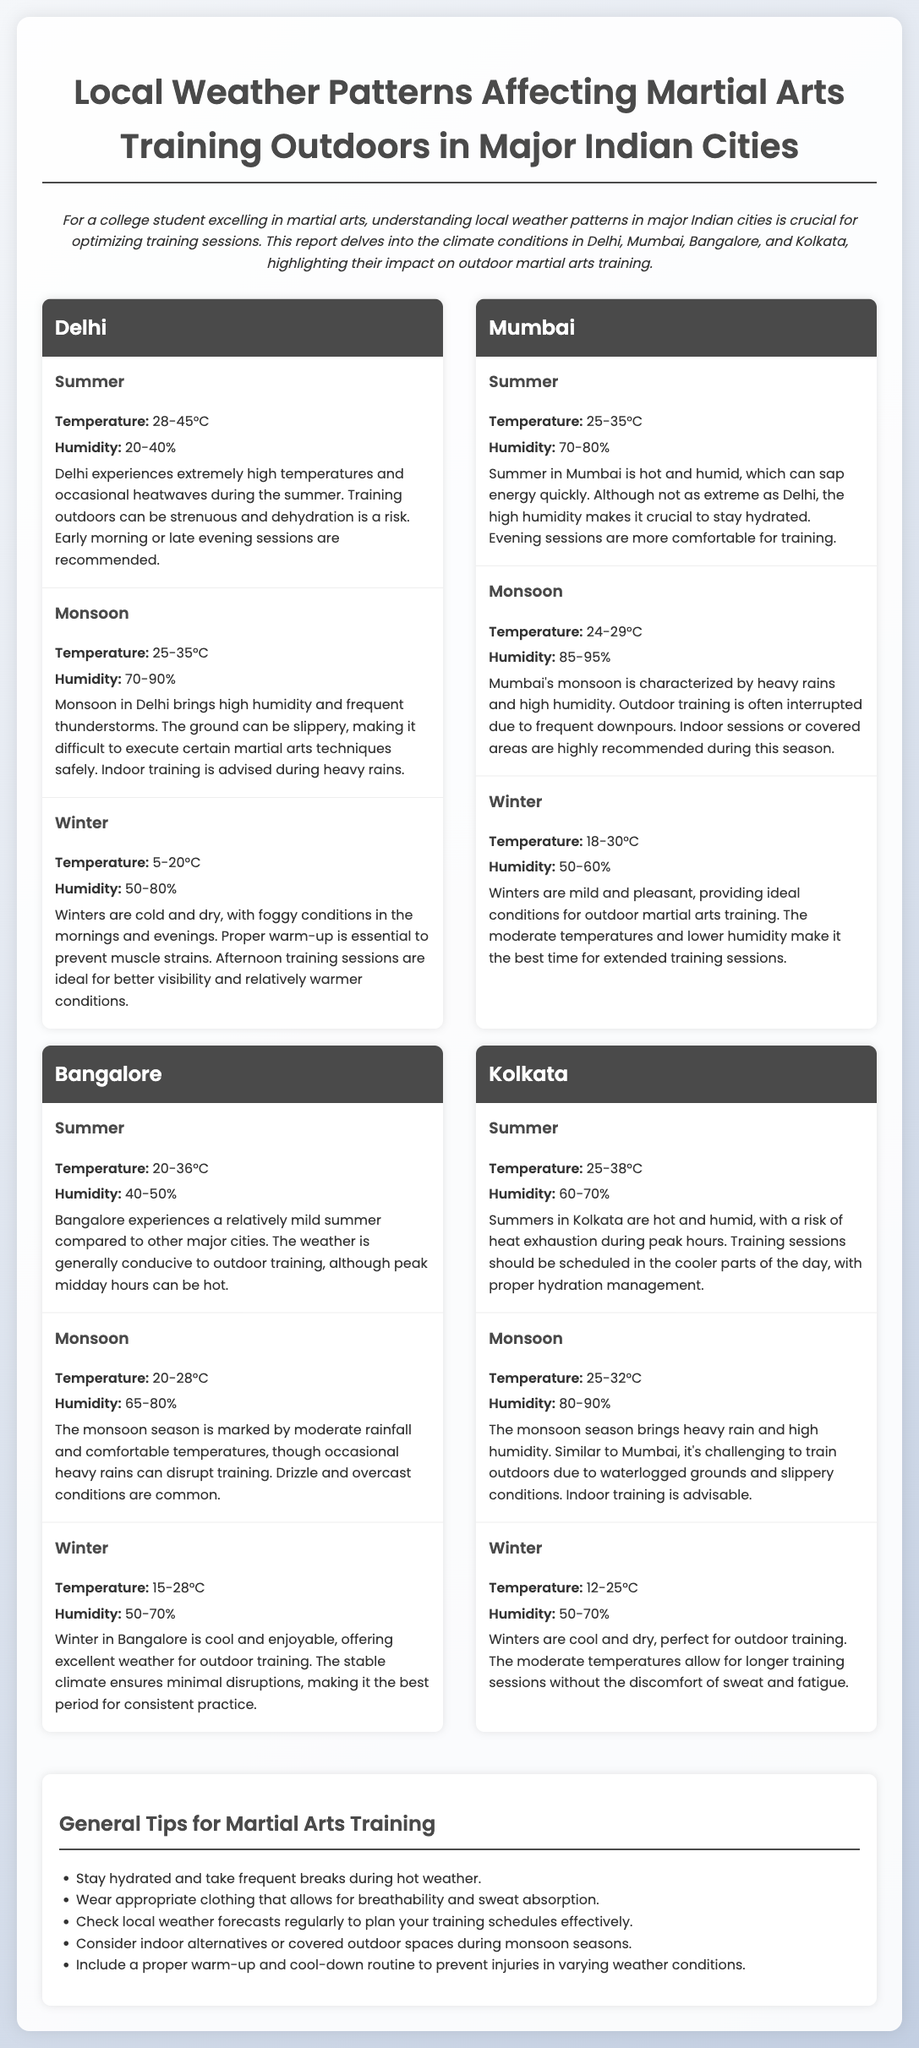What is the recommended training time during Delhi's summer? Delhi's summer experiences extremely high temperatures, and early morning or late evening sessions are recommended to avoid heat.
Answer: Early morning or late evening sessions What is the humidity range during Mumbai's winter? Mumbai's winter has a humidity range of 50-60%, as indicated for the winter season in the document.
Answer: 50-60% What is the temperature range in Bangalore during monsoon? The temperature range during the monsoon season in Bangalore is between 20-28 degrees Celsius, as mentioned in the document.
Answer: 20-28°C What training method is advised during heavy rains in Delhi? Indoor training is advised during heavy rains in Delhi due to high humidity and frequently slippery grounds.
Answer: Indoor training Which city has the highest summer temperature range? Delhi has the highest summer temperature range of 28-45 degrees Celsius among the mentioned cities.
Answer: 28-45°C What characterizes Kolkata's summer weather? Kolkata's summer weather is characterized by heat exhaustion risks, with temperatures between 25-38 degrees Celsius and high humidity levels.
Answer: Hot and humid How is training affected during Mumbai's monsoon? Outdoor training is often interrupted due to heavy rains and high humidity during Mumbai's monsoon season, as indicated in the report.
Answer: Interrupted by heavy rains What general tip is recommended for hot weather? Staying hydrated and taking frequent breaks during hot weather is a recommended general tip for martial arts training.
Answer: Stay hydrated What should be included in a proper warm-up routine? A proper warm-up routine is essential to prevent muscle strains during varying weather conditions, as suggested in the document.
Answer: Essential for preventing muscle strains 